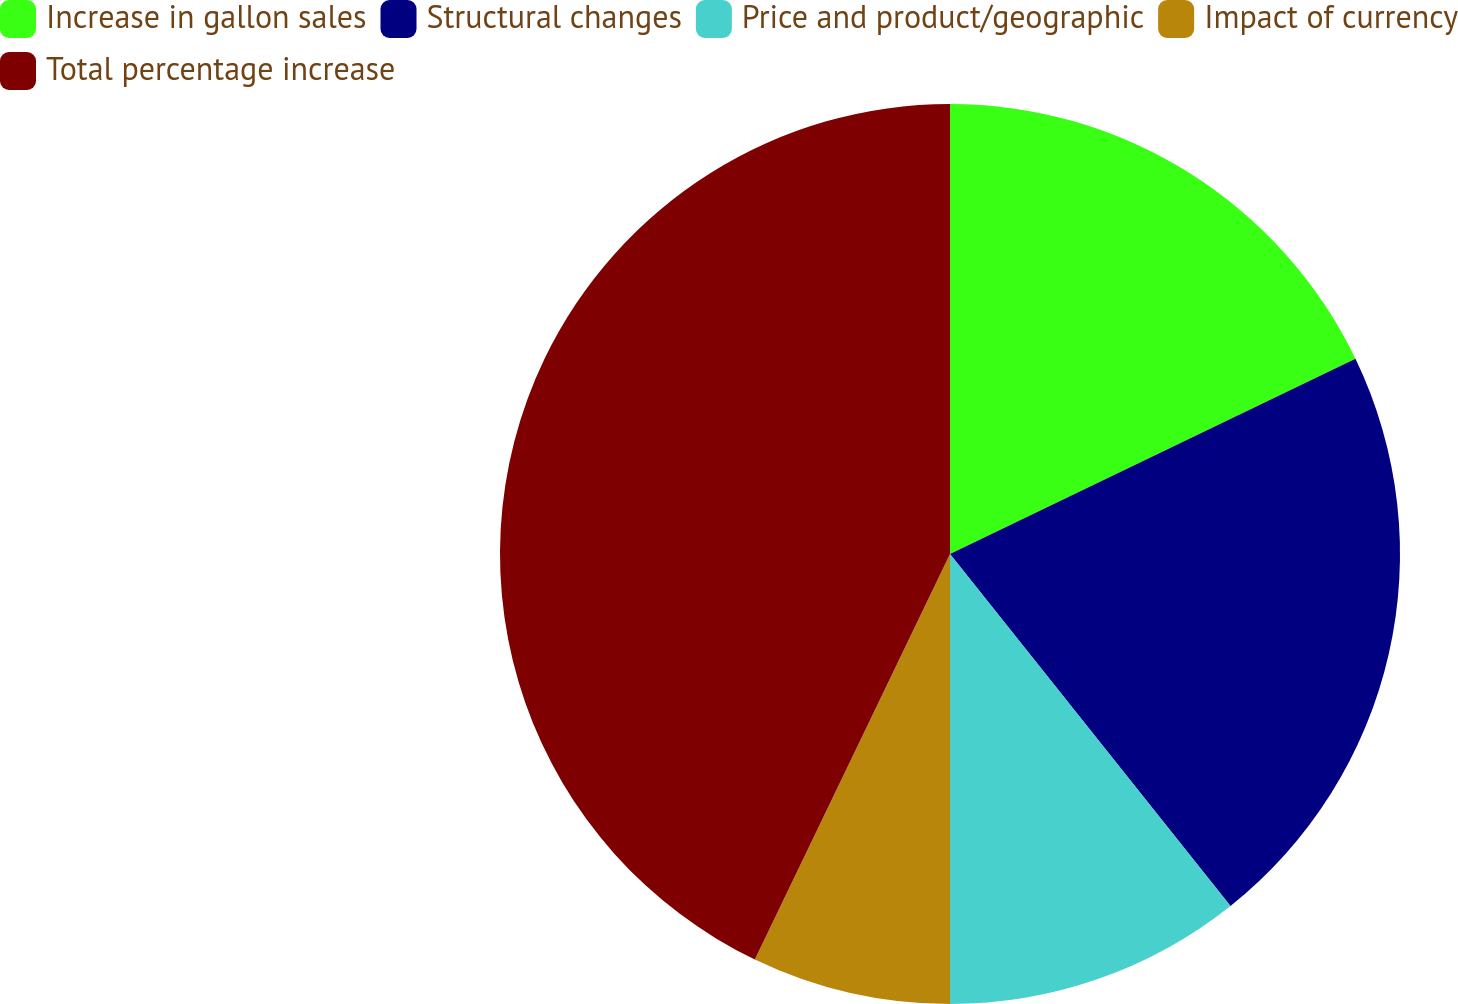Convert chart to OTSL. <chart><loc_0><loc_0><loc_500><loc_500><pie_chart><fcel>Increase in gallon sales<fcel>Structural changes<fcel>Price and product/geographic<fcel>Impact of currency<fcel>Total percentage increase<nl><fcel>17.86%<fcel>21.43%<fcel>10.71%<fcel>7.14%<fcel>42.86%<nl></chart> 